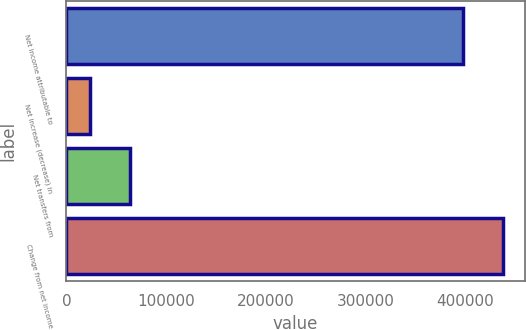Convert chart. <chart><loc_0><loc_0><loc_500><loc_500><bar_chart><fcel>Net income attributable to<fcel>Net increase (decrease) in<fcel>Net transfers from<fcel>Change from net income<nl><fcel>398097<fcel>24090<fcel>63899.7<fcel>437907<nl></chart> 